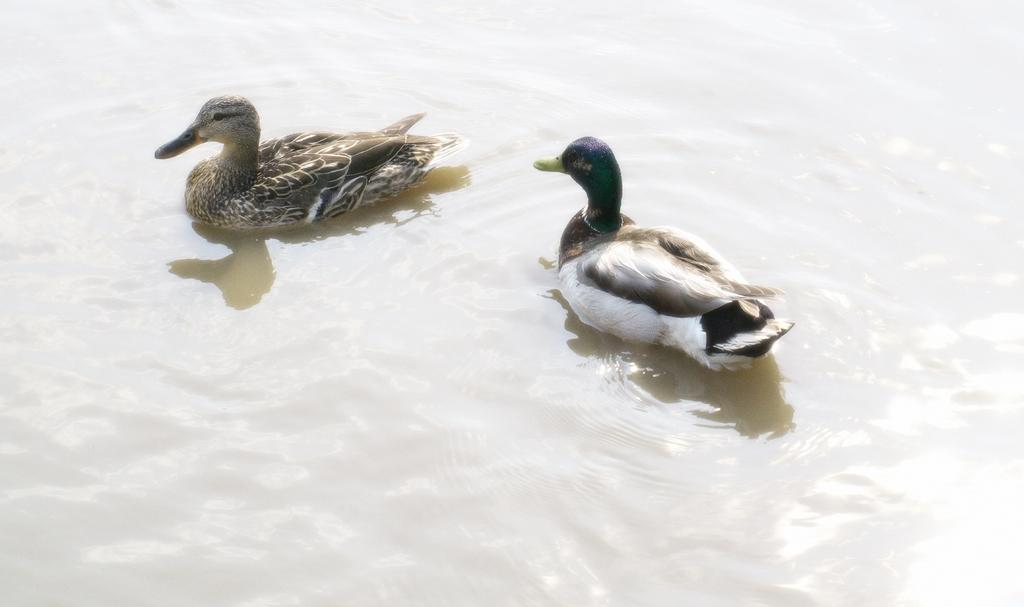What type of animals are in the image? There are ducks in the image. Where are the ducks located? The ducks are on the water. What type of pancake is being discussed by the committee in the image? There is no committee or pancake present in the image; it features ducks on the water. 